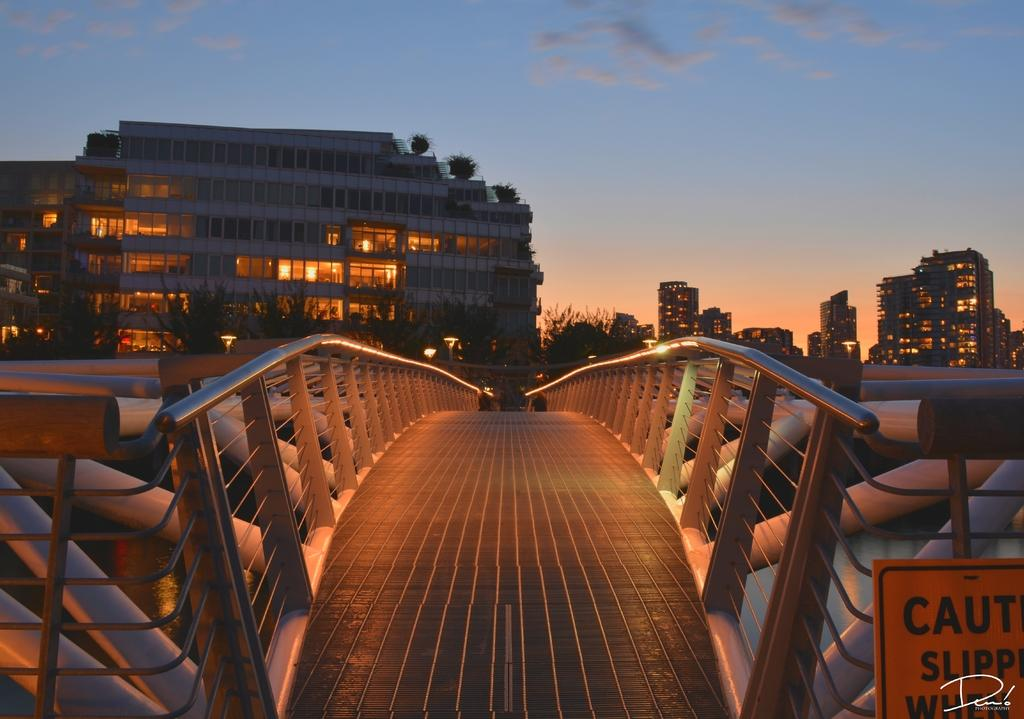<image>
Describe the image concisely. a steel bridge with a sign reading Caution Slippery When 